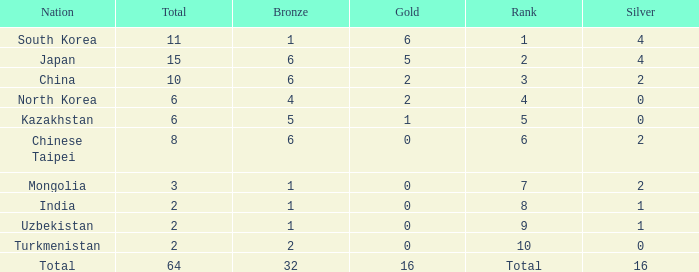What's the biggest Bronze that has less than 0 Silvers? None. Would you mind parsing the complete table? {'header': ['Nation', 'Total', 'Bronze', 'Gold', 'Rank', 'Silver'], 'rows': [['South Korea', '11', '1', '6', '1', '4'], ['Japan', '15', '6', '5', '2', '4'], ['China', '10', '6', '2', '3', '2'], ['North Korea', '6', '4', '2', '4', '0'], ['Kazakhstan', '6', '5', '1', '5', '0'], ['Chinese Taipei', '8', '6', '0', '6', '2'], ['Mongolia', '3', '1', '0', '7', '2'], ['India', '2', '1', '0', '8', '1'], ['Uzbekistan', '2', '1', '0', '9', '1'], ['Turkmenistan', '2', '2', '0', '10', '0'], ['Total', '64', '32', '16', 'Total', '16']]} 